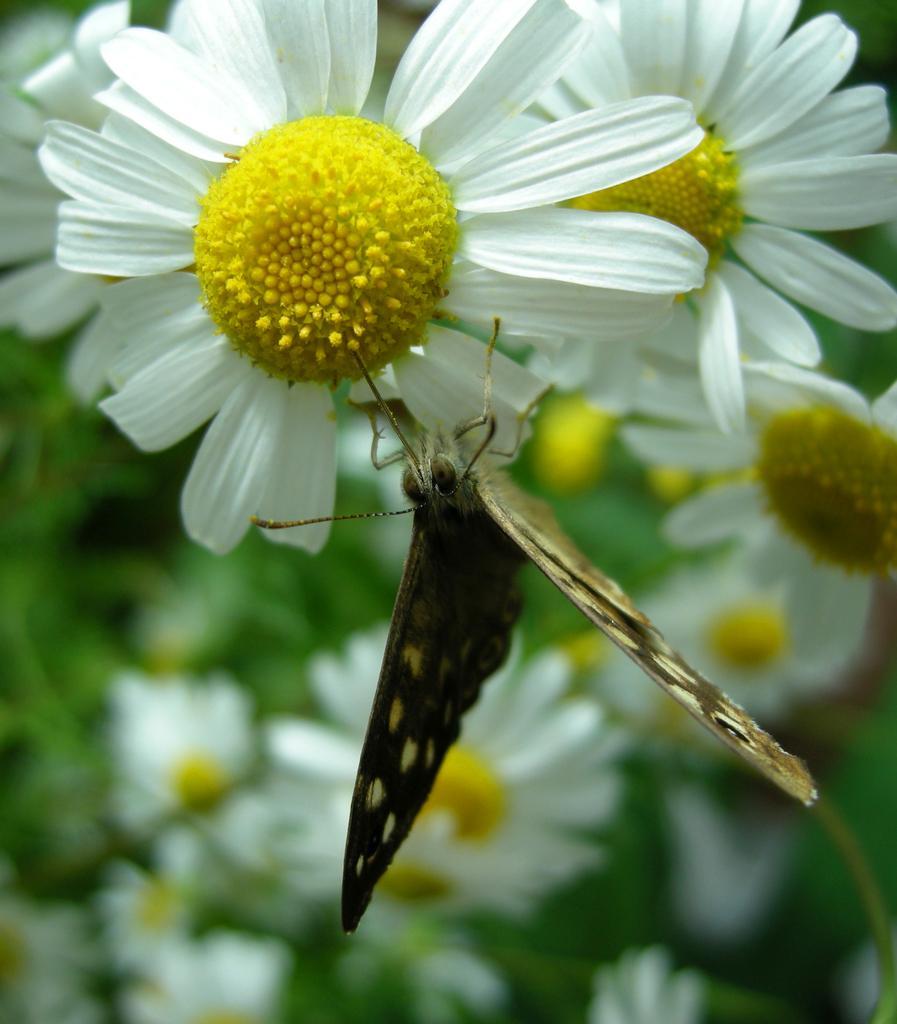Could you give a brief overview of what you see in this image? In this image we can see a butterfly is sitting on white and yellow color flower. Behind so many flowers are there. 